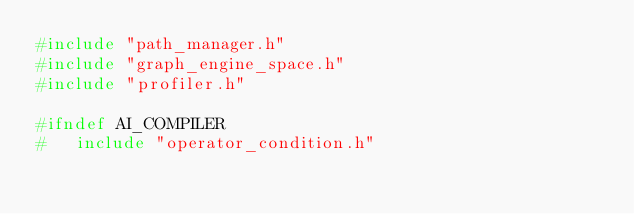<code> <loc_0><loc_0><loc_500><loc_500><_C_>#include "path_manager.h"
#include "graph_engine_space.h"
#include "profiler.h"

#ifndef AI_COMPILER
#	include "operator_condition.h"</code> 